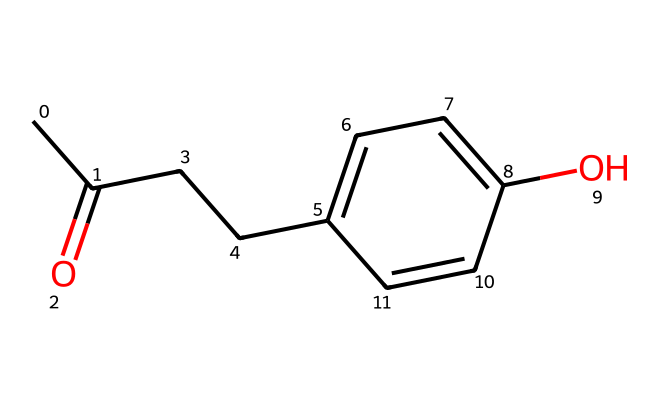What is the functional group present in raspberry ketone? The SMILES representation shows a carbonyl group (C=O), which is characteristic of ketones. This indicates the presence of the ketone functional group in the compound.
Answer: ketone How many aromatic rings are in the structure of raspberry ketone? By analyzing the structure, there is one aromatic ring indicated by the 'c' notations in the SMILES, which signifies the presence of carbon atoms in a cyclic, planar arrangement with alternating double bonds.
Answer: one What type of carbon chain is connected to the aromatic ring in raspberry ketone? The structure contains a straight-chain alkyl group (CC), which is connected to the aromatic ring, showing it is a propanoyl side chain.
Answer: alkyl What is the total number of oxygen atoms in raspberry ketone? In the given SMILES representation, there is one oxygen atom in the carbonyl group (C=O) and another one from the hydroxyl group (-OH), totaling two oxygen atoms in the structure.
Answer: two How many cyclic bonds are present in the structure of raspberry ketone? The presence of the aromatic ring indicates that it has six carbon atoms linked in a circular structure, but as defined by the number of bonds in the ring structure, it is characterized by alternating single and double bonds, indicating the cyclic nature.
Answer: six Does raspberry ketone contain a hydroxyl group? The hydroxyl group is represented by the -OH notation in the SMILES, indicating the presence of an alcohol group attached to the aromatic ring of the ketone.
Answer: yes 